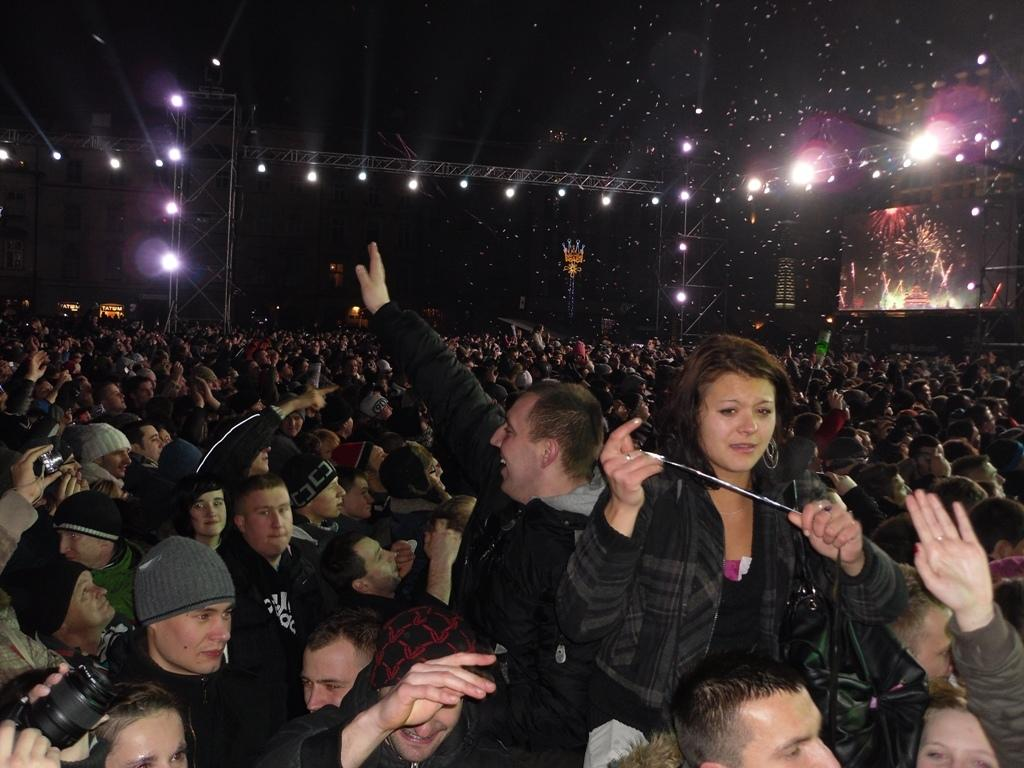What are the people in the image doing? The persons standing on the ground in the image are likely standing or waiting. What can be seen in the background of the image? In the background of the image, there are iron grills, electric lights, buildings, and a dais. What type of structures are visible in the background? The buildings and dais are visible in the background. What kind of lighting is present in the background? Electric lights are present in the background of the image. What year is depicted in the image? There is no indication of a specific year in the image. 